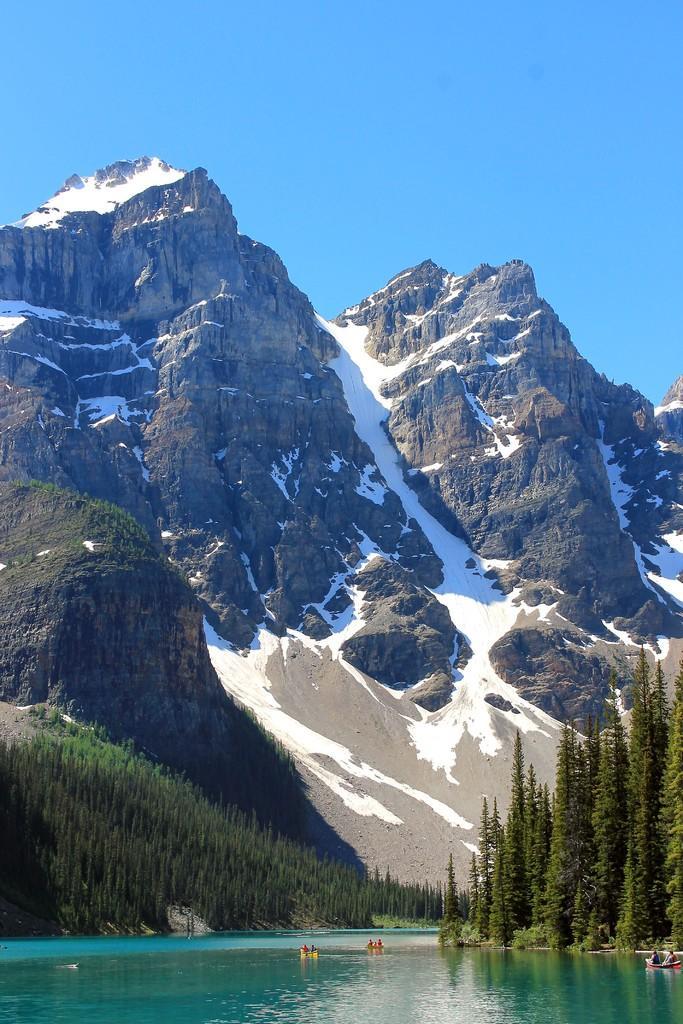Can you describe this image briefly? In the background we can see the sky and it seems like a sunny day. In this picture we can see the hills, trees, water, boats and the people. 